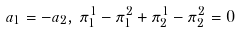Convert formula to latex. <formula><loc_0><loc_0><loc_500><loc_500>a _ { 1 } = - a _ { 2 } , \, \pi _ { 1 } ^ { 1 } - \pi _ { 1 } ^ { 2 } + \pi _ { 2 } ^ { 1 } - \pi _ { 2 } ^ { 2 } = 0</formula> 